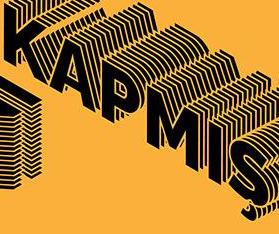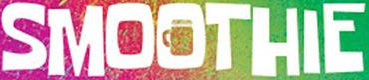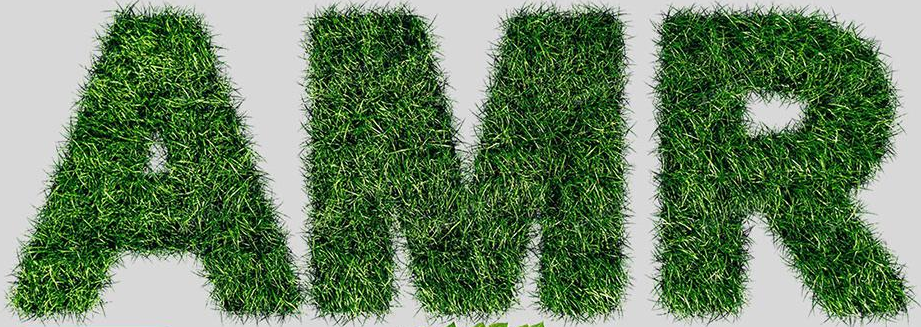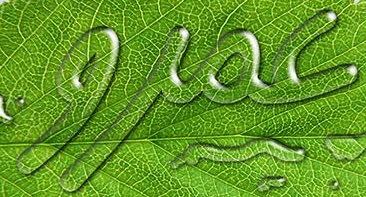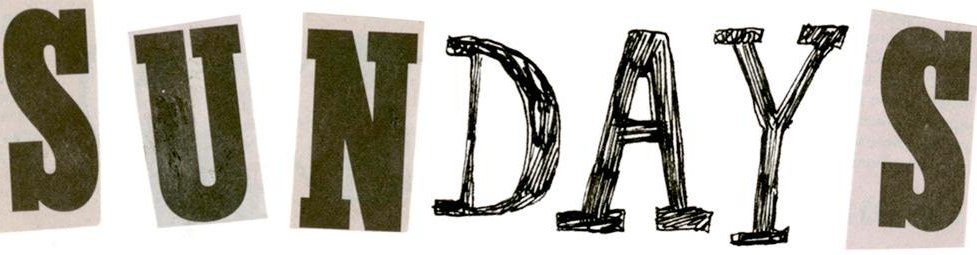Transcribe the words shown in these images in order, separated by a semicolon. KAPMIŞ; SMOOTHIE; AMR; jioc; SUNDAYS 